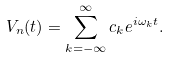Convert formula to latex. <formula><loc_0><loc_0><loc_500><loc_500>V _ { n } ( t ) = \sum _ { k = - \infty } ^ { \infty } c _ { k } e ^ { i \omega _ { k } t } .</formula> 